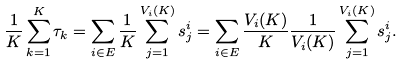Convert formula to latex. <formula><loc_0><loc_0><loc_500><loc_500>\frac { 1 } { K } \sum _ { k = 1 } ^ { K } \tau _ { k } = \sum _ { i \in E } \frac { 1 } { K } \sum _ { j = 1 } ^ { V _ { i } ( K ) } s _ { j } ^ { i } = \sum _ { i \in E } \frac { V _ { i } ( K ) } { K } \frac { 1 } { V _ { i } ( K ) } \sum _ { j = 1 } ^ { V _ { i } ( K ) } s _ { j } ^ { i } .</formula> 